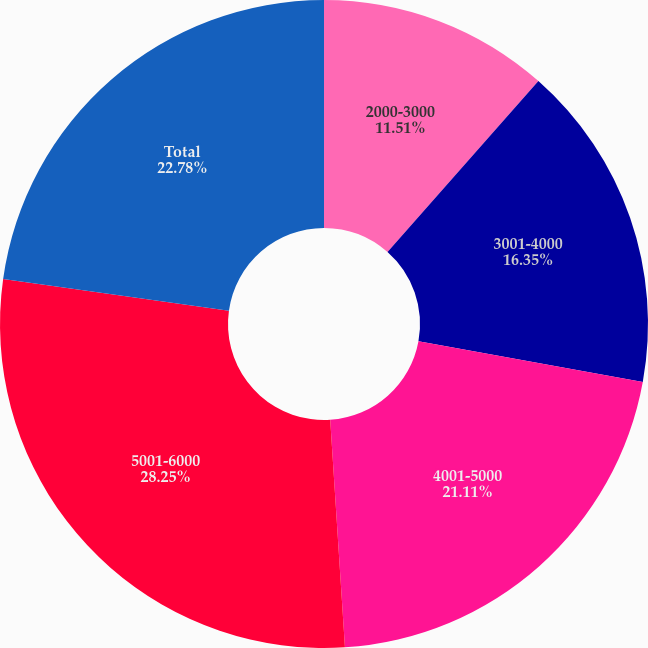Convert chart. <chart><loc_0><loc_0><loc_500><loc_500><pie_chart><fcel>2000-3000<fcel>3001-4000<fcel>4001-5000<fcel>5001-6000<fcel>Total<nl><fcel>11.51%<fcel>16.35%<fcel>21.11%<fcel>28.25%<fcel>22.78%<nl></chart> 